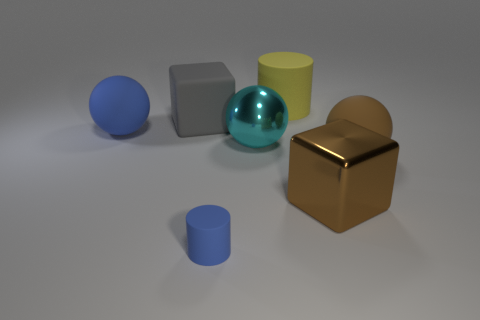What is the material of the ball that is the same color as the large metallic cube?
Ensure brevity in your answer.  Rubber. There is a cylinder to the right of the blue cylinder; is its size the same as the large brown matte sphere?
Ensure brevity in your answer.  Yes. Are there more cyan matte cubes than matte cylinders?
Offer a terse response. No. How many tiny things are either gray matte objects or green metallic cylinders?
Make the answer very short. 0. How many other objects are there of the same color as the big matte cube?
Offer a terse response. 0. How many cubes are made of the same material as the small blue cylinder?
Offer a terse response. 1. Do the ball left of the cyan ball and the metal block have the same color?
Ensure brevity in your answer.  No. What number of brown things are big cylinders or rubber balls?
Offer a terse response. 1. Are there any other things that have the same material as the big yellow thing?
Offer a terse response. Yes. Is the sphere left of the big metal ball made of the same material as the big yellow thing?
Make the answer very short. Yes. 